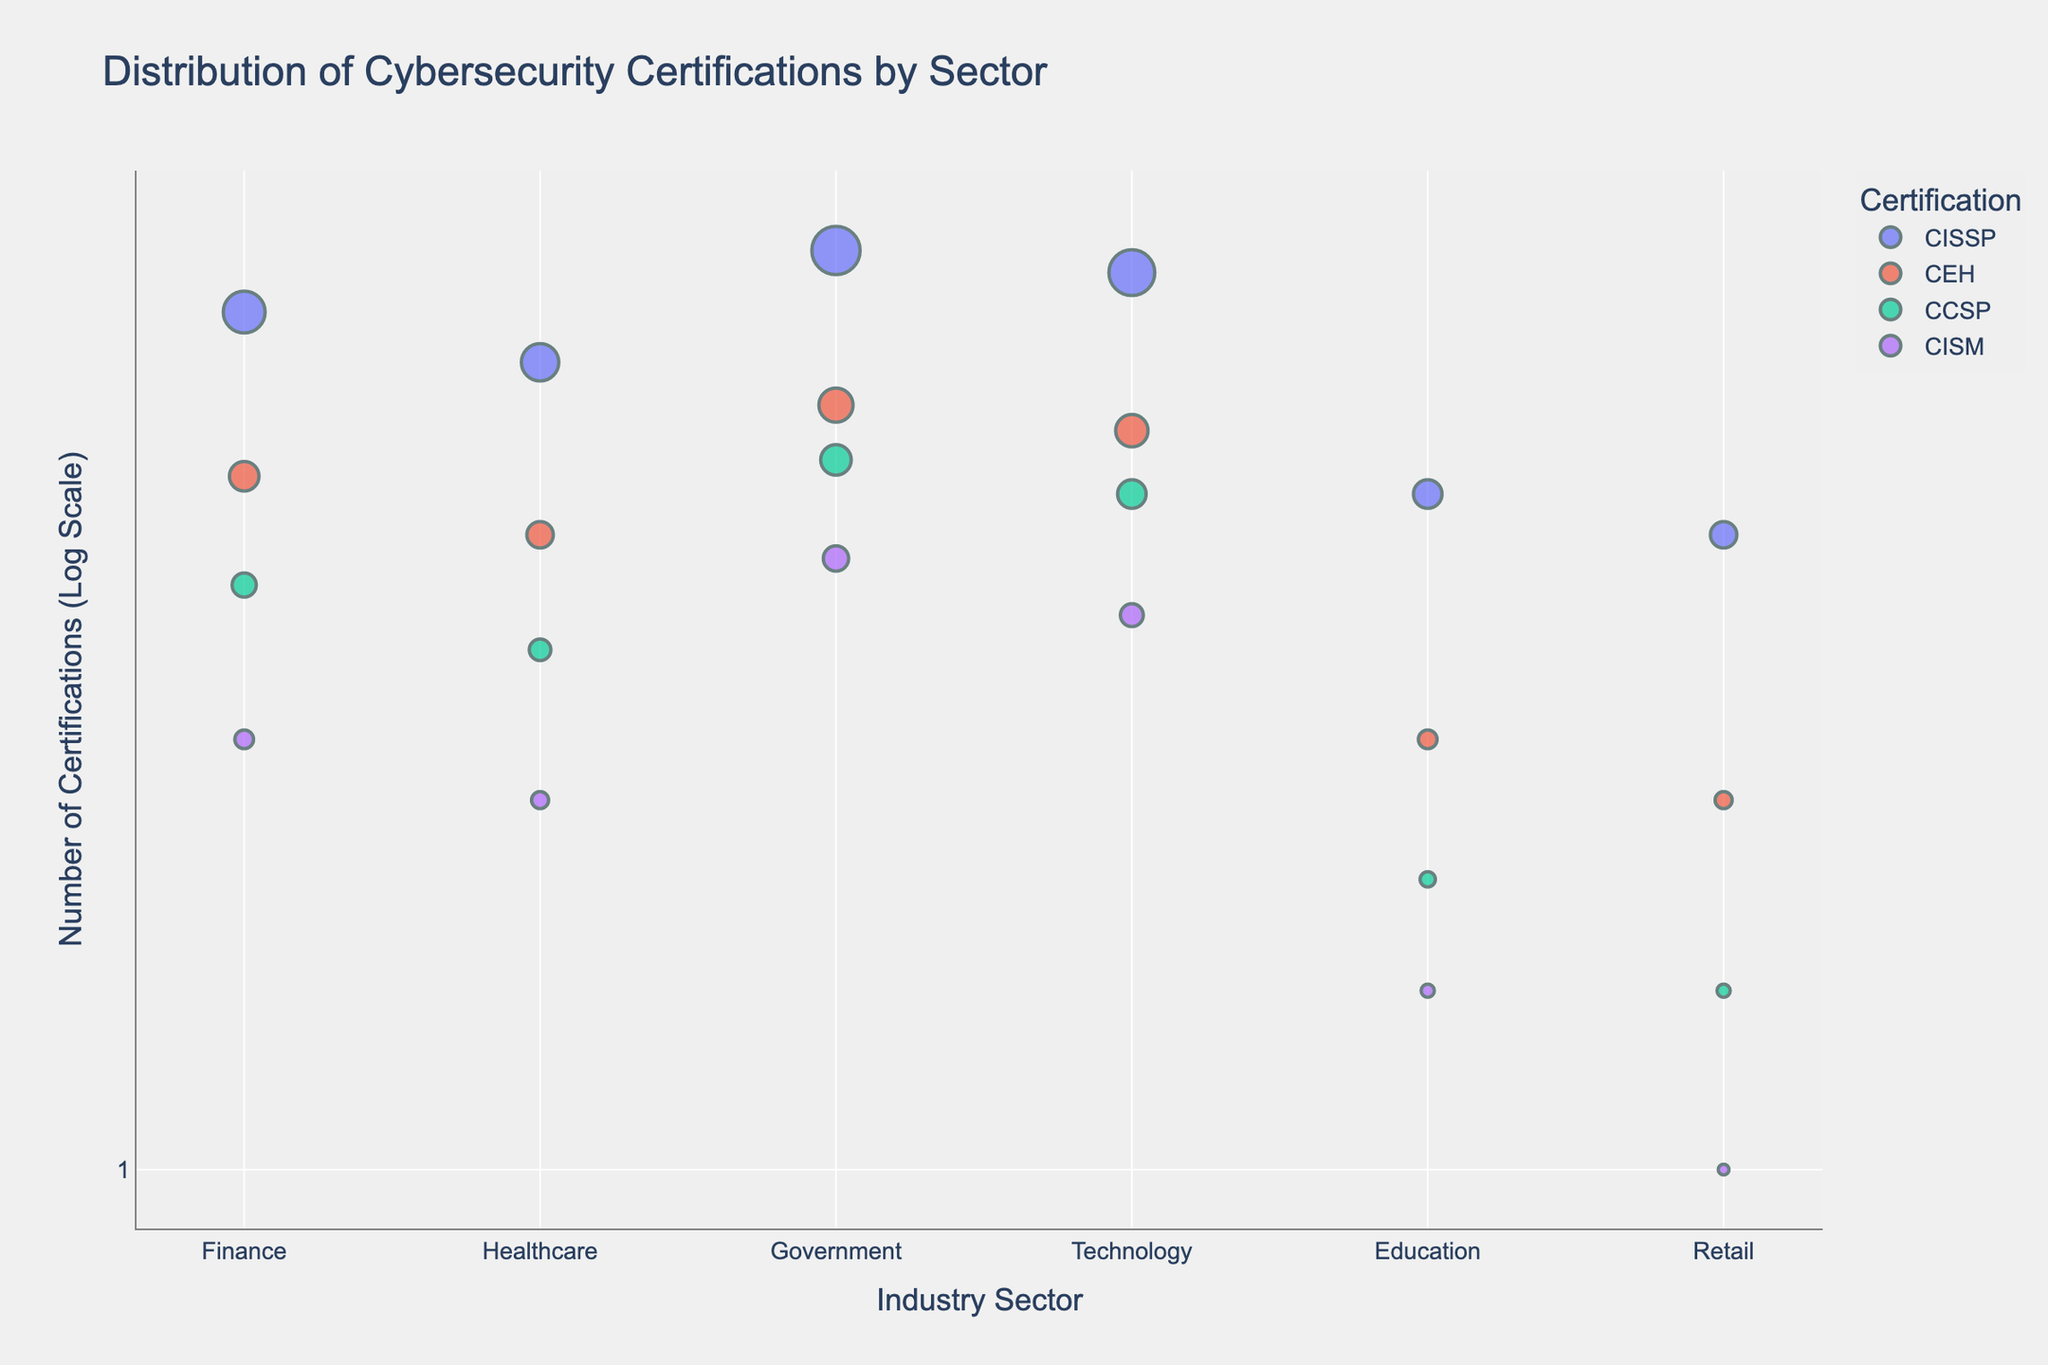What's the title of the scatter plot? The title is at the top of the plot and generally summarizes what the plot is about. Here it's titled 'Distribution of Cybersecurity Certifications by Sector'.
Answer: Distribution of Cybersecurity Certifications by Sector Which sector has the highest count of CISSP certifications? To find the sector with the highest count of CISSP certifications, observe which data point related to the CISSP certification is positioned highest on the y-axis. The Government sector's CISSP certifications data point is the highest.
Answer: Government How does the count of CEH certifications in the Technology sector compare to the count in the Finance sector? Locate the CEH certifications for both Technology and Finance sectors on the plot. The Technology sector's CEH certifications are at a higher position on the y-axis compared to the Finance sector.
Answer: Higher What is the log count of CISM certifications in the Retail sector? Find the data point for CISM certifications under the Retail sector and note its position on the log scale y-axis. The log count of CISM certifications in Retail is 1.
Answer: 1 Which sector shows the lowest count of cybersecurity certifications? Identify the sector with the data points positioned lowest on the log-scale y-axis. The Retail sector shows the lowest count of certifications.
Answer: Retail Between the Finance and Healthcare sectors, which one has more total certifications? Sum up the counts of all certifications in the Finance sector and compare them with the sum in the Healthcare sector. Finance has (150 + 75 + 50 + 30) = 305 certifications, and Healthcare has (120 + 60 + 40 + 25) = 245 certifications. Finance has more certifications.
Answer: Finance In which sector is the CCSP certification least common? Identify the data points for CCSP certification across sectors and find the sector with the lowest position on the log-scale y-axis. The Retail sector has the lowest count for CCSP.
Answer: Retail What is the range of log counts for CEH certifications across all sectors? Find the positions of all data points for CEH certifications on the y-axis. The log counts range from the smallest (Retail, 1.4) to the largest (Government, 2). The range is 2 - 1.4.
Answer: 0.6 Which sectors have more than 100 instances of any certification? Identify sectors with any data points above the log count of 2 (which corresponds to 100). The sectors are Finance (CISSP), Healthcare (CISSP), Government (CISSP, CEH, CCSP), and Technology (CISSP).
Answer: Finance, Healthcare, Government, Technology What proportion of Finance's total certifications are CISSP? Calculate the total number of certifications in Finance (305), then find the proportion of CISSP (150/305). The proportion is approximately 0.49, or 49%.
Answer: 49% 